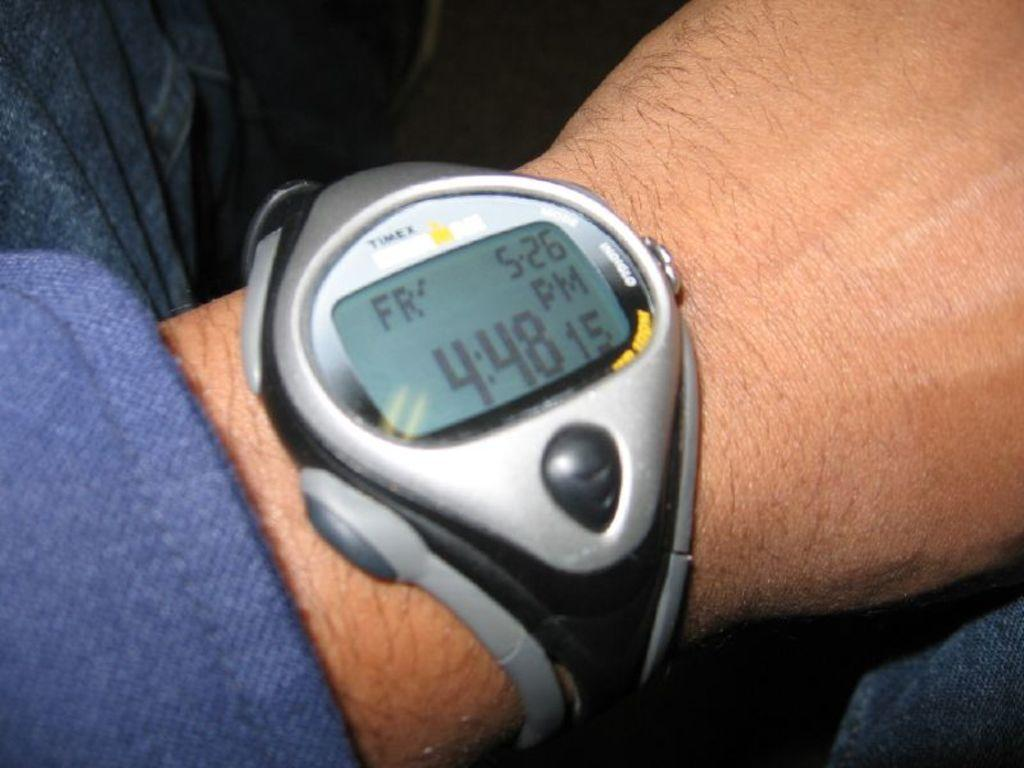What part of a person can be seen in the image? There is a person's hand in the image. What type of watch is the person wearing? The person is wearing a digital watch. What color is the dress the person is wearing? The person is wearing a blue dress. What type of pants is the person wearing? The person is wearing jeans. How would you describe the lighting in the image? The background of the image is dark. What channel is the person watching on the television in the image? There is no television present in the image, so it is not possible to determine what channel the person might be watching. 